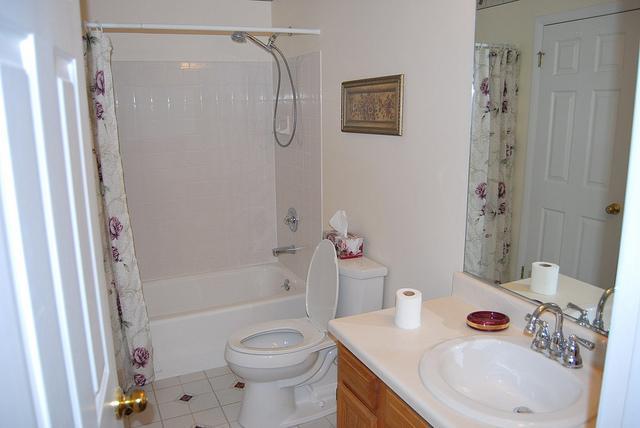How many towels are there?
Give a very brief answer. 0. How many sinks are there?
Give a very brief answer. 1. How many white teddy bears are on the chair?
Give a very brief answer. 0. 